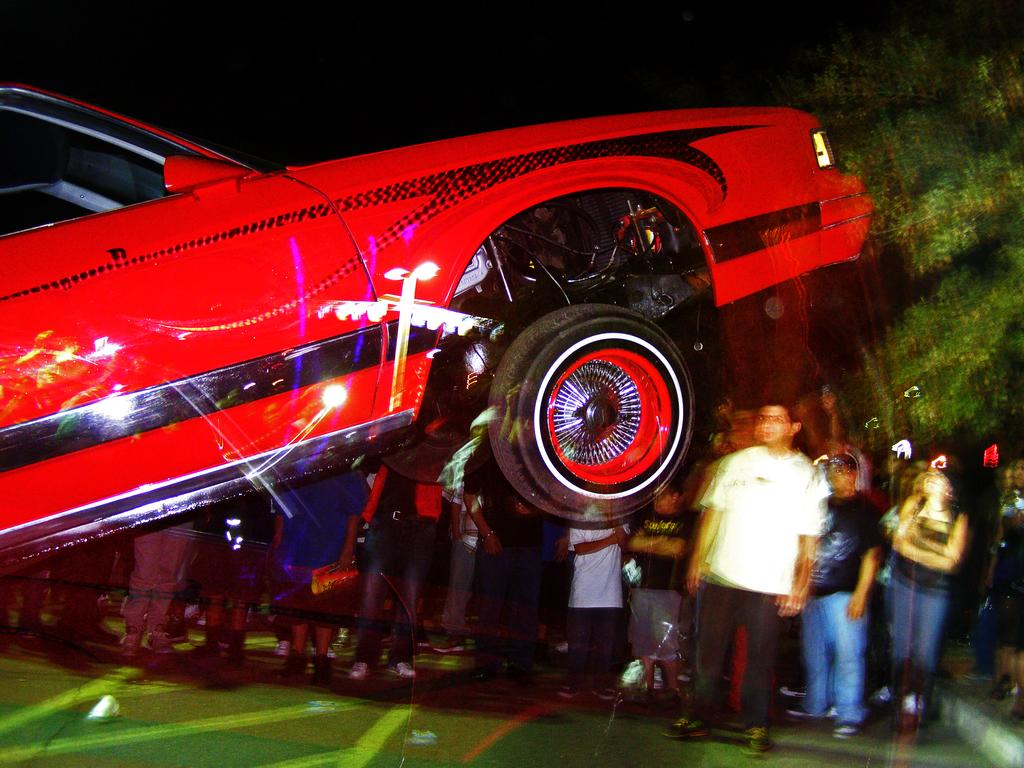What type of vehicle is in the foreground of the image? There is a red colored car in the foreground of the image. What is the position of the car in the image? The car's body is partially in the air. What can be seen in the background of the image? There is a crowd and trees in the background of the image. What type of furniture is being used as bait for the bears in the image? There is no furniture or bears present in the image. 